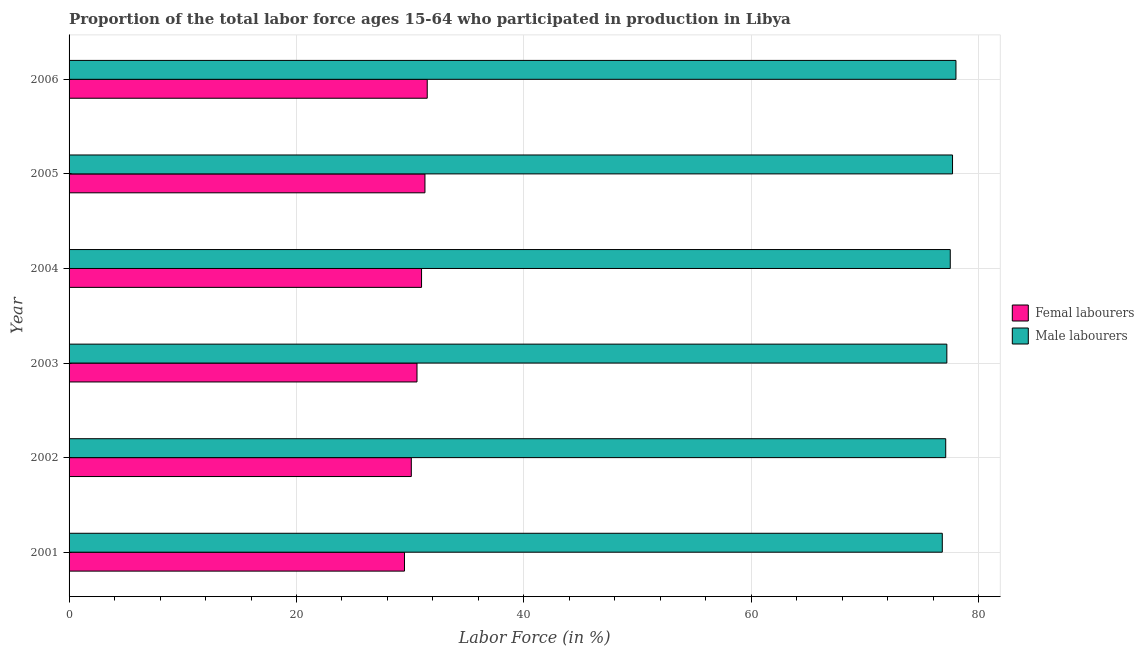How many different coloured bars are there?
Make the answer very short. 2. Are the number of bars per tick equal to the number of legend labels?
Ensure brevity in your answer.  Yes. Are the number of bars on each tick of the Y-axis equal?
Your response must be concise. Yes. How many bars are there on the 1st tick from the top?
Provide a short and direct response. 2. How many bars are there on the 2nd tick from the bottom?
Provide a short and direct response. 2. In how many cases, is the number of bars for a given year not equal to the number of legend labels?
Offer a very short reply. 0. What is the percentage of female labor force in 2006?
Offer a very short reply. 31.5. Across all years, what is the minimum percentage of male labour force?
Ensure brevity in your answer.  76.8. In which year was the percentage of female labor force maximum?
Your answer should be compact. 2006. What is the total percentage of male labour force in the graph?
Offer a very short reply. 464.3. What is the difference between the percentage of male labour force in 2006 and the percentage of female labor force in 2002?
Offer a very short reply. 47.9. What is the average percentage of female labor force per year?
Make the answer very short. 30.67. In the year 2006, what is the difference between the percentage of male labour force and percentage of female labor force?
Give a very brief answer. 46.5. What is the difference between the highest and the second highest percentage of female labor force?
Ensure brevity in your answer.  0.2. What is the difference between the highest and the lowest percentage of female labor force?
Provide a short and direct response. 2. In how many years, is the percentage of female labor force greater than the average percentage of female labor force taken over all years?
Your answer should be compact. 3. Is the sum of the percentage of female labor force in 2001 and 2004 greater than the maximum percentage of male labour force across all years?
Provide a short and direct response. No. What does the 2nd bar from the top in 2003 represents?
Offer a very short reply. Femal labourers. What does the 2nd bar from the bottom in 2002 represents?
Offer a very short reply. Male labourers. Are all the bars in the graph horizontal?
Your answer should be very brief. Yes. Are the values on the major ticks of X-axis written in scientific E-notation?
Give a very brief answer. No. Does the graph contain any zero values?
Make the answer very short. No. Does the graph contain grids?
Make the answer very short. Yes. Where does the legend appear in the graph?
Ensure brevity in your answer.  Center right. How many legend labels are there?
Offer a terse response. 2. How are the legend labels stacked?
Offer a terse response. Vertical. What is the title of the graph?
Provide a succinct answer. Proportion of the total labor force ages 15-64 who participated in production in Libya. What is the label or title of the X-axis?
Give a very brief answer. Labor Force (in %). What is the Labor Force (in %) of Femal labourers in 2001?
Ensure brevity in your answer.  29.5. What is the Labor Force (in %) of Male labourers in 2001?
Make the answer very short. 76.8. What is the Labor Force (in %) of Femal labourers in 2002?
Make the answer very short. 30.1. What is the Labor Force (in %) in Male labourers in 2002?
Your response must be concise. 77.1. What is the Labor Force (in %) of Femal labourers in 2003?
Offer a terse response. 30.6. What is the Labor Force (in %) of Male labourers in 2003?
Offer a terse response. 77.2. What is the Labor Force (in %) in Male labourers in 2004?
Your answer should be very brief. 77.5. What is the Labor Force (in %) in Femal labourers in 2005?
Give a very brief answer. 31.3. What is the Labor Force (in %) of Male labourers in 2005?
Offer a very short reply. 77.7. What is the Labor Force (in %) in Femal labourers in 2006?
Offer a terse response. 31.5. What is the Labor Force (in %) of Male labourers in 2006?
Ensure brevity in your answer.  78. Across all years, what is the maximum Labor Force (in %) in Femal labourers?
Your response must be concise. 31.5. Across all years, what is the maximum Labor Force (in %) in Male labourers?
Make the answer very short. 78. Across all years, what is the minimum Labor Force (in %) of Femal labourers?
Keep it short and to the point. 29.5. Across all years, what is the minimum Labor Force (in %) in Male labourers?
Provide a succinct answer. 76.8. What is the total Labor Force (in %) in Femal labourers in the graph?
Your answer should be very brief. 184. What is the total Labor Force (in %) in Male labourers in the graph?
Keep it short and to the point. 464.3. What is the difference between the Labor Force (in %) of Femal labourers in 2001 and that in 2002?
Your response must be concise. -0.6. What is the difference between the Labor Force (in %) in Male labourers in 2001 and that in 2002?
Offer a terse response. -0.3. What is the difference between the Labor Force (in %) in Femal labourers in 2001 and that in 2003?
Make the answer very short. -1.1. What is the difference between the Labor Force (in %) of Male labourers in 2001 and that in 2003?
Make the answer very short. -0.4. What is the difference between the Labor Force (in %) of Male labourers in 2001 and that in 2004?
Keep it short and to the point. -0.7. What is the difference between the Labor Force (in %) of Male labourers in 2001 and that in 2006?
Offer a terse response. -1.2. What is the difference between the Labor Force (in %) of Male labourers in 2002 and that in 2004?
Provide a short and direct response. -0.4. What is the difference between the Labor Force (in %) of Femal labourers in 2002 and that in 2006?
Keep it short and to the point. -1.4. What is the difference between the Labor Force (in %) in Femal labourers in 2003 and that in 2004?
Your response must be concise. -0.4. What is the difference between the Labor Force (in %) of Femal labourers in 2003 and that in 2005?
Your answer should be compact. -0.7. What is the difference between the Labor Force (in %) in Male labourers in 2003 and that in 2006?
Offer a terse response. -0.8. What is the difference between the Labor Force (in %) of Femal labourers in 2004 and that in 2005?
Offer a very short reply. -0.3. What is the difference between the Labor Force (in %) of Male labourers in 2004 and that in 2006?
Make the answer very short. -0.5. What is the difference between the Labor Force (in %) in Femal labourers in 2001 and the Labor Force (in %) in Male labourers in 2002?
Give a very brief answer. -47.6. What is the difference between the Labor Force (in %) in Femal labourers in 2001 and the Labor Force (in %) in Male labourers in 2003?
Give a very brief answer. -47.7. What is the difference between the Labor Force (in %) in Femal labourers in 2001 and the Labor Force (in %) in Male labourers in 2004?
Your answer should be very brief. -48. What is the difference between the Labor Force (in %) of Femal labourers in 2001 and the Labor Force (in %) of Male labourers in 2005?
Your answer should be compact. -48.2. What is the difference between the Labor Force (in %) in Femal labourers in 2001 and the Labor Force (in %) in Male labourers in 2006?
Ensure brevity in your answer.  -48.5. What is the difference between the Labor Force (in %) in Femal labourers in 2002 and the Labor Force (in %) in Male labourers in 2003?
Ensure brevity in your answer.  -47.1. What is the difference between the Labor Force (in %) in Femal labourers in 2002 and the Labor Force (in %) in Male labourers in 2004?
Ensure brevity in your answer.  -47.4. What is the difference between the Labor Force (in %) of Femal labourers in 2002 and the Labor Force (in %) of Male labourers in 2005?
Make the answer very short. -47.6. What is the difference between the Labor Force (in %) in Femal labourers in 2002 and the Labor Force (in %) in Male labourers in 2006?
Your answer should be compact. -47.9. What is the difference between the Labor Force (in %) in Femal labourers in 2003 and the Labor Force (in %) in Male labourers in 2004?
Your answer should be very brief. -46.9. What is the difference between the Labor Force (in %) in Femal labourers in 2003 and the Labor Force (in %) in Male labourers in 2005?
Ensure brevity in your answer.  -47.1. What is the difference between the Labor Force (in %) of Femal labourers in 2003 and the Labor Force (in %) of Male labourers in 2006?
Offer a terse response. -47.4. What is the difference between the Labor Force (in %) of Femal labourers in 2004 and the Labor Force (in %) of Male labourers in 2005?
Give a very brief answer. -46.7. What is the difference between the Labor Force (in %) of Femal labourers in 2004 and the Labor Force (in %) of Male labourers in 2006?
Your response must be concise. -47. What is the difference between the Labor Force (in %) in Femal labourers in 2005 and the Labor Force (in %) in Male labourers in 2006?
Keep it short and to the point. -46.7. What is the average Labor Force (in %) of Femal labourers per year?
Your response must be concise. 30.67. What is the average Labor Force (in %) in Male labourers per year?
Offer a terse response. 77.38. In the year 2001, what is the difference between the Labor Force (in %) of Femal labourers and Labor Force (in %) of Male labourers?
Provide a succinct answer. -47.3. In the year 2002, what is the difference between the Labor Force (in %) in Femal labourers and Labor Force (in %) in Male labourers?
Provide a succinct answer. -47. In the year 2003, what is the difference between the Labor Force (in %) of Femal labourers and Labor Force (in %) of Male labourers?
Make the answer very short. -46.6. In the year 2004, what is the difference between the Labor Force (in %) of Femal labourers and Labor Force (in %) of Male labourers?
Your answer should be very brief. -46.5. In the year 2005, what is the difference between the Labor Force (in %) in Femal labourers and Labor Force (in %) in Male labourers?
Keep it short and to the point. -46.4. In the year 2006, what is the difference between the Labor Force (in %) in Femal labourers and Labor Force (in %) in Male labourers?
Make the answer very short. -46.5. What is the ratio of the Labor Force (in %) in Femal labourers in 2001 to that in 2002?
Make the answer very short. 0.98. What is the ratio of the Labor Force (in %) in Femal labourers in 2001 to that in 2003?
Your answer should be very brief. 0.96. What is the ratio of the Labor Force (in %) of Male labourers in 2001 to that in 2003?
Ensure brevity in your answer.  0.99. What is the ratio of the Labor Force (in %) of Femal labourers in 2001 to that in 2004?
Ensure brevity in your answer.  0.95. What is the ratio of the Labor Force (in %) of Male labourers in 2001 to that in 2004?
Your answer should be very brief. 0.99. What is the ratio of the Labor Force (in %) of Femal labourers in 2001 to that in 2005?
Your answer should be compact. 0.94. What is the ratio of the Labor Force (in %) in Male labourers in 2001 to that in 2005?
Give a very brief answer. 0.99. What is the ratio of the Labor Force (in %) of Femal labourers in 2001 to that in 2006?
Keep it short and to the point. 0.94. What is the ratio of the Labor Force (in %) in Male labourers in 2001 to that in 2006?
Your answer should be very brief. 0.98. What is the ratio of the Labor Force (in %) of Femal labourers in 2002 to that in 2003?
Provide a succinct answer. 0.98. What is the ratio of the Labor Force (in %) of Male labourers in 2002 to that in 2003?
Your answer should be very brief. 1. What is the ratio of the Labor Force (in %) of Male labourers in 2002 to that in 2004?
Offer a very short reply. 0.99. What is the ratio of the Labor Force (in %) of Femal labourers in 2002 to that in 2005?
Ensure brevity in your answer.  0.96. What is the ratio of the Labor Force (in %) in Femal labourers in 2002 to that in 2006?
Offer a terse response. 0.96. What is the ratio of the Labor Force (in %) in Femal labourers in 2003 to that in 2004?
Your response must be concise. 0.99. What is the ratio of the Labor Force (in %) in Male labourers in 2003 to that in 2004?
Offer a very short reply. 1. What is the ratio of the Labor Force (in %) in Femal labourers in 2003 to that in 2005?
Offer a terse response. 0.98. What is the ratio of the Labor Force (in %) in Femal labourers in 2003 to that in 2006?
Make the answer very short. 0.97. What is the ratio of the Labor Force (in %) of Femal labourers in 2004 to that in 2005?
Provide a succinct answer. 0.99. What is the ratio of the Labor Force (in %) in Femal labourers in 2004 to that in 2006?
Your answer should be compact. 0.98. What is the ratio of the Labor Force (in %) of Male labourers in 2004 to that in 2006?
Give a very brief answer. 0.99. What is the ratio of the Labor Force (in %) of Male labourers in 2005 to that in 2006?
Provide a succinct answer. 1. What is the difference between the highest and the lowest Labor Force (in %) in Male labourers?
Your answer should be very brief. 1.2. 